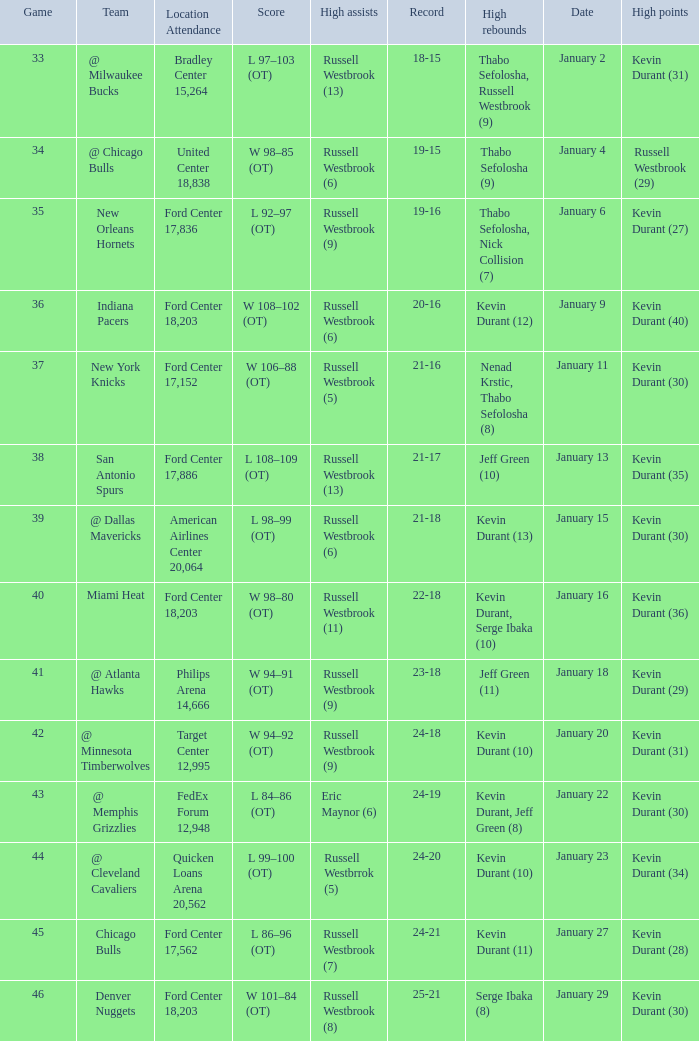Name the least game for january 29 46.0. Help me parse the entirety of this table. {'header': ['Game', 'Team', 'Location Attendance', 'Score', 'High assists', 'Record', 'High rebounds', 'Date', 'High points'], 'rows': [['33', '@ Milwaukee Bucks', 'Bradley Center 15,264', 'L 97–103 (OT)', 'Russell Westbrook (13)', '18-15', 'Thabo Sefolosha, Russell Westbrook (9)', 'January 2', 'Kevin Durant (31)'], ['34', '@ Chicago Bulls', 'United Center 18,838', 'W 98–85 (OT)', 'Russell Westbrook (6)', '19-15', 'Thabo Sefolosha (9)', 'January 4', 'Russell Westbrook (29)'], ['35', 'New Orleans Hornets', 'Ford Center 17,836', 'L 92–97 (OT)', 'Russell Westbrook (9)', '19-16', 'Thabo Sefolosha, Nick Collision (7)', 'January 6', 'Kevin Durant (27)'], ['36', 'Indiana Pacers', 'Ford Center 18,203', 'W 108–102 (OT)', 'Russell Westbrook (6)', '20-16', 'Kevin Durant (12)', 'January 9', 'Kevin Durant (40)'], ['37', 'New York Knicks', 'Ford Center 17,152', 'W 106–88 (OT)', 'Russell Westbrook (5)', '21-16', 'Nenad Krstic, Thabo Sefolosha (8)', 'January 11', 'Kevin Durant (30)'], ['38', 'San Antonio Spurs', 'Ford Center 17,886', 'L 108–109 (OT)', 'Russell Westbrook (13)', '21-17', 'Jeff Green (10)', 'January 13', 'Kevin Durant (35)'], ['39', '@ Dallas Mavericks', 'American Airlines Center 20,064', 'L 98–99 (OT)', 'Russell Westbrook (6)', '21-18', 'Kevin Durant (13)', 'January 15', 'Kevin Durant (30)'], ['40', 'Miami Heat', 'Ford Center 18,203', 'W 98–80 (OT)', 'Russell Westbrook (11)', '22-18', 'Kevin Durant, Serge Ibaka (10)', 'January 16', 'Kevin Durant (36)'], ['41', '@ Atlanta Hawks', 'Philips Arena 14,666', 'W 94–91 (OT)', 'Russell Westbrook (9)', '23-18', 'Jeff Green (11)', 'January 18', 'Kevin Durant (29)'], ['42', '@ Minnesota Timberwolves', 'Target Center 12,995', 'W 94–92 (OT)', 'Russell Westbrook (9)', '24-18', 'Kevin Durant (10)', 'January 20', 'Kevin Durant (31)'], ['43', '@ Memphis Grizzlies', 'FedEx Forum 12,948', 'L 84–86 (OT)', 'Eric Maynor (6)', '24-19', 'Kevin Durant, Jeff Green (8)', 'January 22', 'Kevin Durant (30)'], ['44', '@ Cleveland Cavaliers', 'Quicken Loans Arena 20,562', 'L 99–100 (OT)', 'Russell Westbrrok (5)', '24-20', 'Kevin Durant (10)', 'January 23', 'Kevin Durant (34)'], ['45', 'Chicago Bulls', 'Ford Center 17,562', 'L 86–96 (OT)', 'Russell Westbrook (7)', '24-21', 'Kevin Durant (11)', 'January 27', 'Kevin Durant (28)'], ['46', 'Denver Nuggets', 'Ford Center 18,203', 'W 101–84 (OT)', 'Russell Westbrook (8)', '25-21', 'Serge Ibaka (8)', 'January 29', 'Kevin Durant (30)']]} 